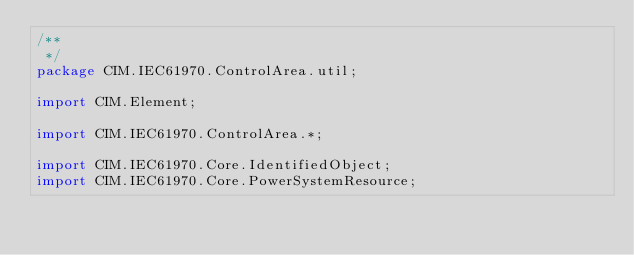<code> <loc_0><loc_0><loc_500><loc_500><_Java_>/**
 */
package CIM.IEC61970.ControlArea.util;

import CIM.Element;

import CIM.IEC61970.ControlArea.*;

import CIM.IEC61970.Core.IdentifiedObject;
import CIM.IEC61970.Core.PowerSystemResource;
</code> 